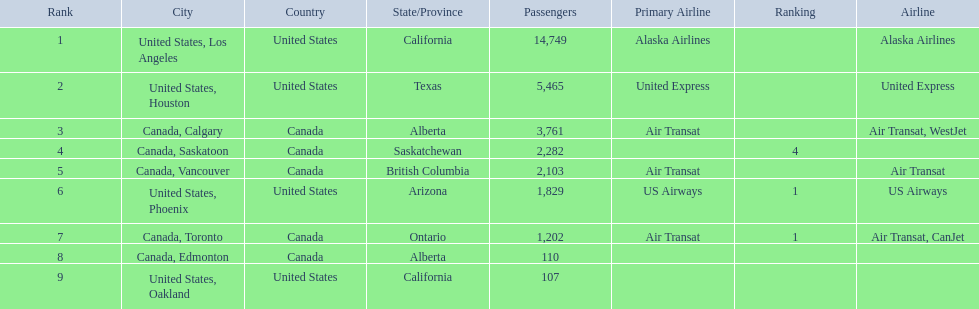Which cities had less than 2,000 passengers? United States, Phoenix, Canada, Toronto, Canada, Edmonton, United States, Oakland. Of these cities, which had fewer than 1,000 passengers? Canada, Edmonton, United States, Oakland. Of the cities in the previous answer, which one had only 107 passengers? United States, Oakland. 